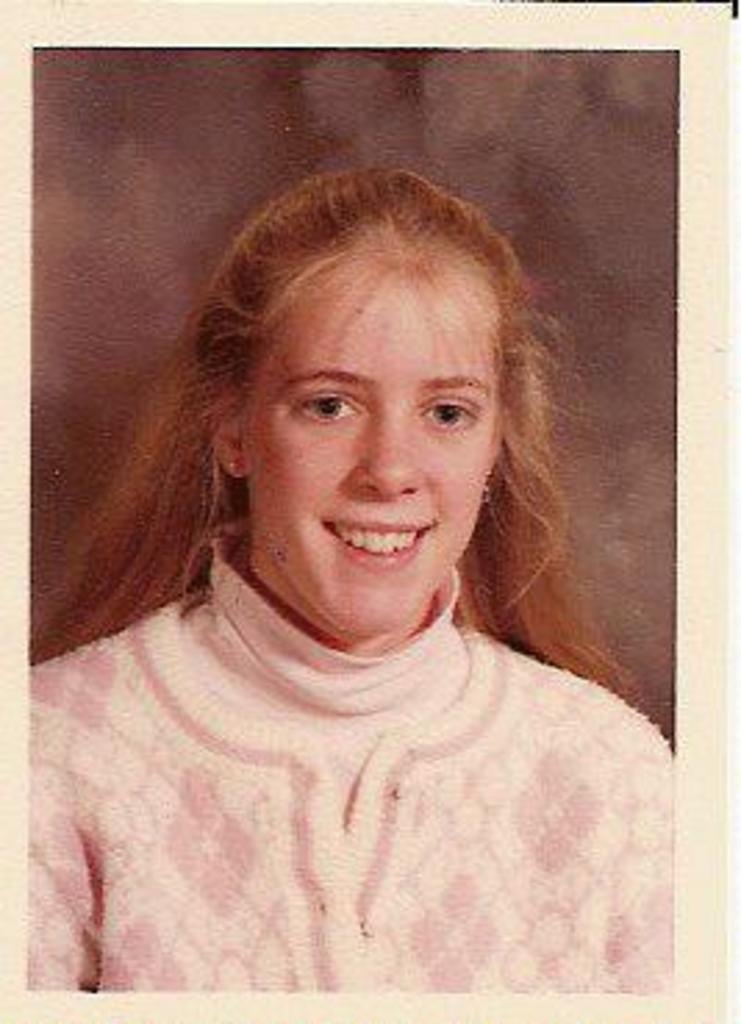In one or two sentences, can you explain what this image depicts? In this picture we can see the photograph of a woman and she is smiling. 